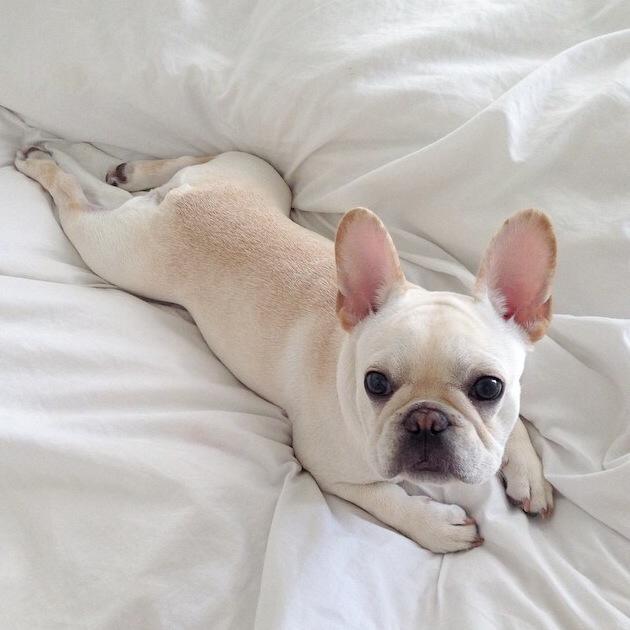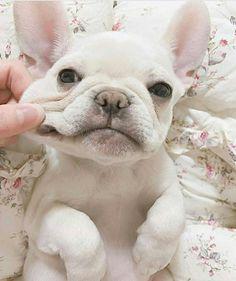The first image is the image on the left, the second image is the image on the right. For the images displayed, is the sentence "One dog is standing." factually correct? Answer yes or no. No. The first image is the image on the left, the second image is the image on the right. For the images displayed, is the sentence "One image shows a french bulldog standing on all fours, and the other image includes a white bulldog looking straight at the camera." factually correct? Answer yes or no. No. 